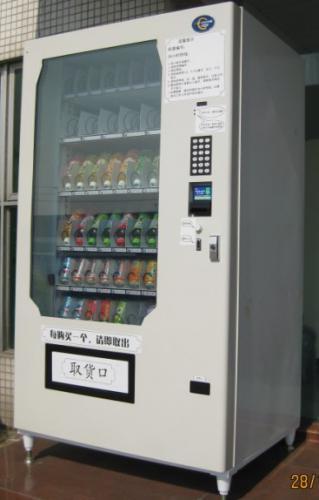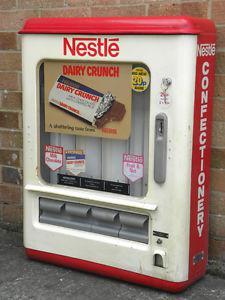The first image is the image on the left, the second image is the image on the right. Assess this claim about the two images: "A vending machine has distinctive black and white markings.". Correct or not? Answer yes or no. No. 